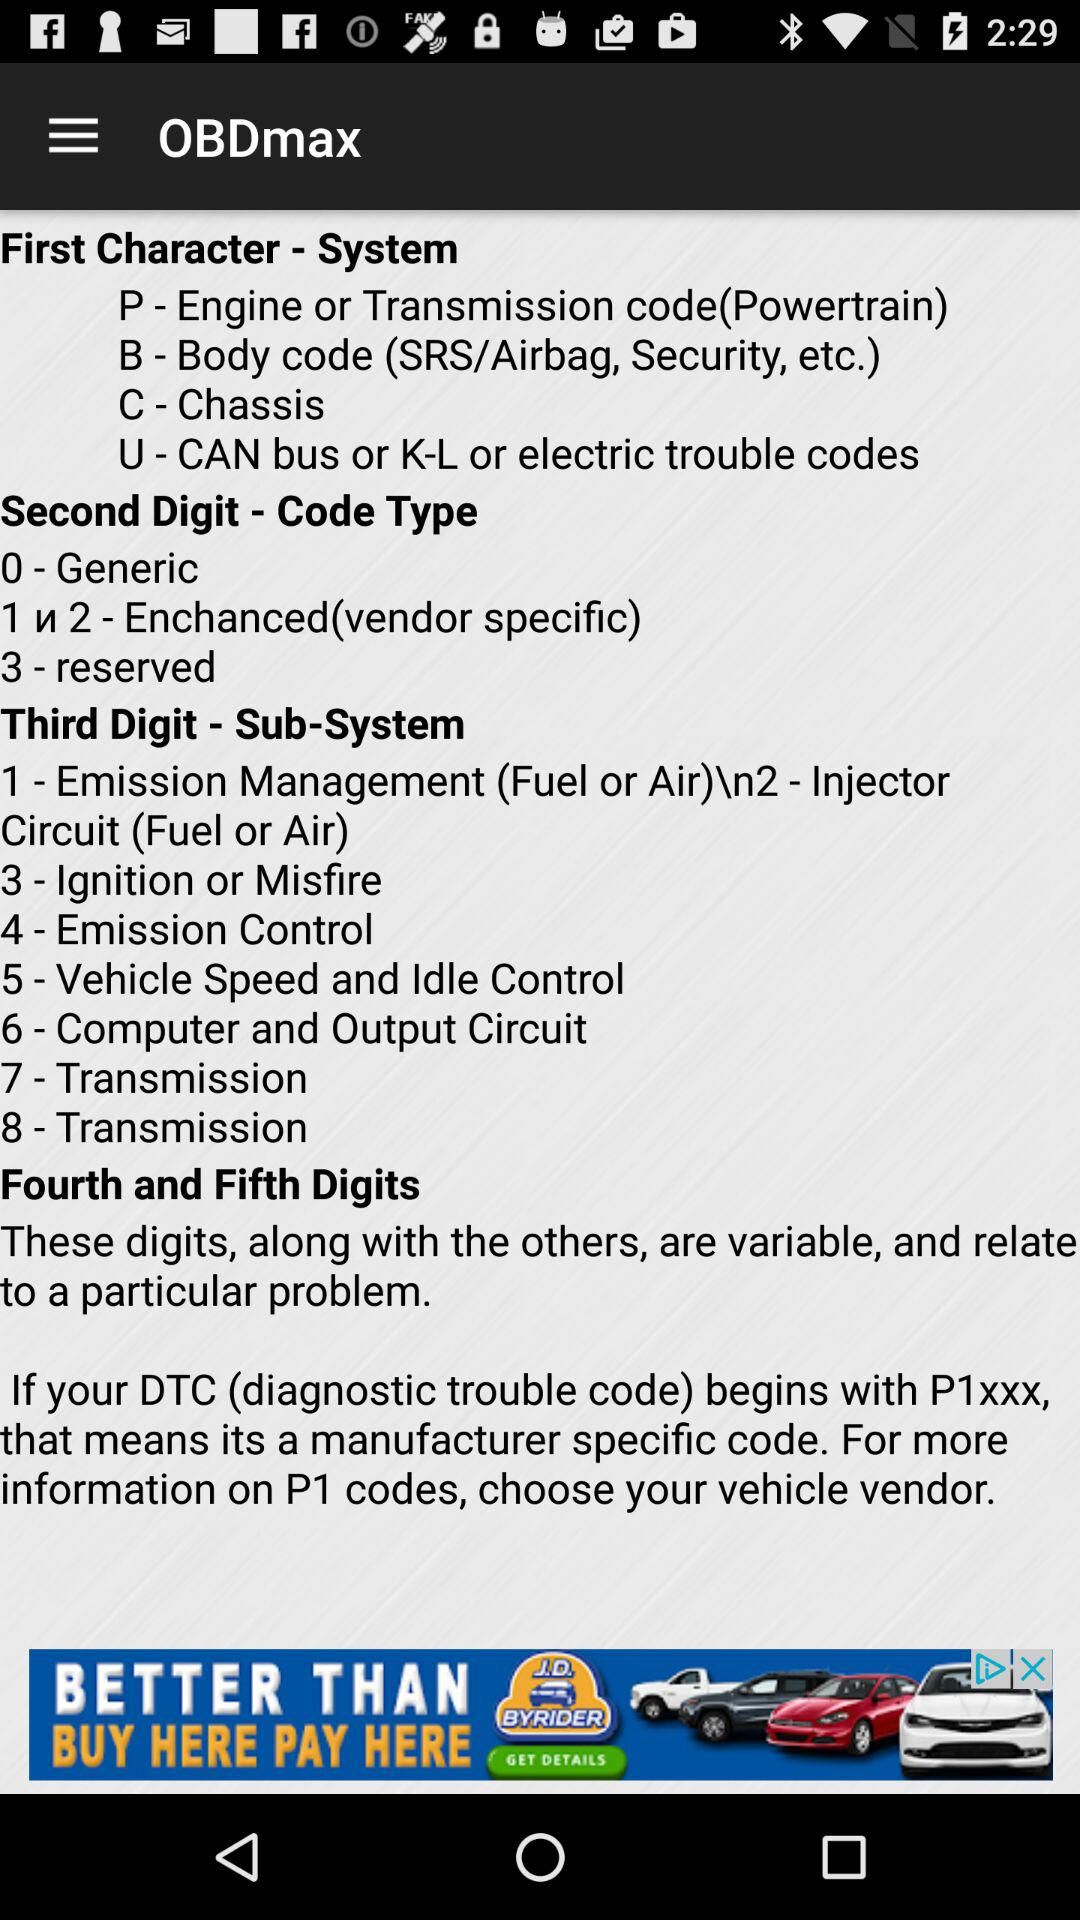What is the user's diagnostic trouble code?
When the provided information is insufficient, respond with <no answer>. <no answer> 